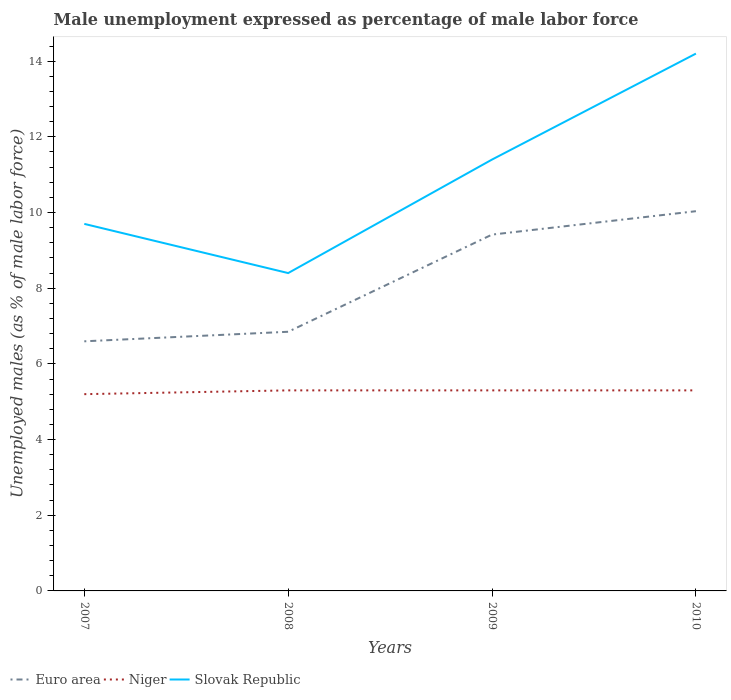Does the line corresponding to Slovak Republic intersect with the line corresponding to Euro area?
Give a very brief answer. No. Across all years, what is the maximum unemployment in males in in Euro area?
Your answer should be compact. 6.6. In which year was the unemployment in males in in Slovak Republic maximum?
Give a very brief answer. 2008. What is the total unemployment in males in in Niger in the graph?
Your response must be concise. -0.1. What is the difference between the highest and the second highest unemployment in males in in Euro area?
Ensure brevity in your answer.  3.44. What is the difference between the highest and the lowest unemployment in males in in Niger?
Your answer should be compact. 3. How many years are there in the graph?
Offer a terse response. 4. Does the graph contain any zero values?
Keep it short and to the point. No. Where does the legend appear in the graph?
Your answer should be compact. Bottom left. How many legend labels are there?
Provide a short and direct response. 3. How are the legend labels stacked?
Give a very brief answer. Horizontal. What is the title of the graph?
Give a very brief answer. Male unemployment expressed as percentage of male labor force. Does "Turkmenistan" appear as one of the legend labels in the graph?
Make the answer very short. No. What is the label or title of the X-axis?
Give a very brief answer. Years. What is the label or title of the Y-axis?
Your response must be concise. Unemployed males (as % of male labor force). What is the Unemployed males (as % of male labor force) of Euro area in 2007?
Provide a short and direct response. 6.6. What is the Unemployed males (as % of male labor force) of Niger in 2007?
Make the answer very short. 5.2. What is the Unemployed males (as % of male labor force) of Slovak Republic in 2007?
Ensure brevity in your answer.  9.7. What is the Unemployed males (as % of male labor force) in Euro area in 2008?
Ensure brevity in your answer.  6.85. What is the Unemployed males (as % of male labor force) in Niger in 2008?
Provide a succinct answer. 5.3. What is the Unemployed males (as % of male labor force) in Slovak Republic in 2008?
Keep it short and to the point. 8.4. What is the Unemployed males (as % of male labor force) in Euro area in 2009?
Keep it short and to the point. 9.42. What is the Unemployed males (as % of male labor force) of Niger in 2009?
Offer a terse response. 5.3. What is the Unemployed males (as % of male labor force) in Slovak Republic in 2009?
Provide a short and direct response. 11.4. What is the Unemployed males (as % of male labor force) in Euro area in 2010?
Provide a succinct answer. 10.04. What is the Unemployed males (as % of male labor force) of Niger in 2010?
Provide a short and direct response. 5.3. What is the Unemployed males (as % of male labor force) in Slovak Republic in 2010?
Make the answer very short. 14.2. Across all years, what is the maximum Unemployed males (as % of male labor force) in Euro area?
Offer a very short reply. 10.04. Across all years, what is the maximum Unemployed males (as % of male labor force) of Niger?
Your answer should be compact. 5.3. Across all years, what is the maximum Unemployed males (as % of male labor force) of Slovak Republic?
Ensure brevity in your answer.  14.2. Across all years, what is the minimum Unemployed males (as % of male labor force) in Euro area?
Ensure brevity in your answer.  6.6. Across all years, what is the minimum Unemployed males (as % of male labor force) of Niger?
Provide a succinct answer. 5.2. Across all years, what is the minimum Unemployed males (as % of male labor force) in Slovak Republic?
Your response must be concise. 8.4. What is the total Unemployed males (as % of male labor force) of Euro area in the graph?
Offer a very short reply. 32.9. What is the total Unemployed males (as % of male labor force) in Niger in the graph?
Your response must be concise. 21.1. What is the total Unemployed males (as % of male labor force) of Slovak Republic in the graph?
Offer a terse response. 43.7. What is the difference between the Unemployed males (as % of male labor force) of Euro area in 2007 and that in 2008?
Give a very brief answer. -0.25. What is the difference between the Unemployed males (as % of male labor force) of Niger in 2007 and that in 2008?
Give a very brief answer. -0.1. What is the difference between the Unemployed males (as % of male labor force) of Euro area in 2007 and that in 2009?
Provide a succinct answer. -2.82. What is the difference between the Unemployed males (as % of male labor force) of Euro area in 2007 and that in 2010?
Ensure brevity in your answer.  -3.44. What is the difference between the Unemployed males (as % of male labor force) of Niger in 2007 and that in 2010?
Ensure brevity in your answer.  -0.1. What is the difference between the Unemployed males (as % of male labor force) in Slovak Republic in 2007 and that in 2010?
Offer a terse response. -4.5. What is the difference between the Unemployed males (as % of male labor force) in Euro area in 2008 and that in 2009?
Your answer should be very brief. -2.57. What is the difference between the Unemployed males (as % of male labor force) in Niger in 2008 and that in 2009?
Your answer should be very brief. 0. What is the difference between the Unemployed males (as % of male labor force) of Slovak Republic in 2008 and that in 2009?
Offer a terse response. -3. What is the difference between the Unemployed males (as % of male labor force) of Euro area in 2008 and that in 2010?
Make the answer very short. -3.19. What is the difference between the Unemployed males (as % of male labor force) of Euro area in 2009 and that in 2010?
Keep it short and to the point. -0.62. What is the difference between the Unemployed males (as % of male labor force) in Euro area in 2007 and the Unemployed males (as % of male labor force) in Niger in 2008?
Provide a succinct answer. 1.3. What is the difference between the Unemployed males (as % of male labor force) of Euro area in 2007 and the Unemployed males (as % of male labor force) of Slovak Republic in 2008?
Offer a very short reply. -1.8. What is the difference between the Unemployed males (as % of male labor force) in Niger in 2007 and the Unemployed males (as % of male labor force) in Slovak Republic in 2008?
Ensure brevity in your answer.  -3.2. What is the difference between the Unemployed males (as % of male labor force) in Euro area in 2007 and the Unemployed males (as % of male labor force) in Niger in 2009?
Make the answer very short. 1.3. What is the difference between the Unemployed males (as % of male labor force) of Euro area in 2007 and the Unemployed males (as % of male labor force) of Slovak Republic in 2009?
Your answer should be compact. -4.8. What is the difference between the Unemployed males (as % of male labor force) of Niger in 2007 and the Unemployed males (as % of male labor force) of Slovak Republic in 2009?
Offer a very short reply. -6.2. What is the difference between the Unemployed males (as % of male labor force) in Euro area in 2007 and the Unemployed males (as % of male labor force) in Niger in 2010?
Offer a very short reply. 1.3. What is the difference between the Unemployed males (as % of male labor force) of Euro area in 2007 and the Unemployed males (as % of male labor force) of Slovak Republic in 2010?
Your answer should be compact. -7.6. What is the difference between the Unemployed males (as % of male labor force) of Niger in 2007 and the Unemployed males (as % of male labor force) of Slovak Republic in 2010?
Your response must be concise. -9. What is the difference between the Unemployed males (as % of male labor force) in Euro area in 2008 and the Unemployed males (as % of male labor force) in Niger in 2009?
Offer a very short reply. 1.55. What is the difference between the Unemployed males (as % of male labor force) in Euro area in 2008 and the Unemployed males (as % of male labor force) in Slovak Republic in 2009?
Ensure brevity in your answer.  -4.55. What is the difference between the Unemployed males (as % of male labor force) in Euro area in 2008 and the Unemployed males (as % of male labor force) in Niger in 2010?
Make the answer very short. 1.55. What is the difference between the Unemployed males (as % of male labor force) in Euro area in 2008 and the Unemployed males (as % of male labor force) in Slovak Republic in 2010?
Provide a short and direct response. -7.35. What is the difference between the Unemployed males (as % of male labor force) of Euro area in 2009 and the Unemployed males (as % of male labor force) of Niger in 2010?
Your response must be concise. 4.12. What is the difference between the Unemployed males (as % of male labor force) in Euro area in 2009 and the Unemployed males (as % of male labor force) in Slovak Republic in 2010?
Provide a short and direct response. -4.78. What is the difference between the Unemployed males (as % of male labor force) of Niger in 2009 and the Unemployed males (as % of male labor force) of Slovak Republic in 2010?
Your response must be concise. -8.9. What is the average Unemployed males (as % of male labor force) of Euro area per year?
Offer a terse response. 8.22. What is the average Unemployed males (as % of male labor force) in Niger per year?
Your response must be concise. 5.28. What is the average Unemployed males (as % of male labor force) of Slovak Republic per year?
Offer a very short reply. 10.93. In the year 2007, what is the difference between the Unemployed males (as % of male labor force) in Euro area and Unemployed males (as % of male labor force) in Niger?
Your answer should be compact. 1.4. In the year 2007, what is the difference between the Unemployed males (as % of male labor force) of Euro area and Unemployed males (as % of male labor force) of Slovak Republic?
Your answer should be very brief. -3.1. In the year 2007, what is the difference between the Unemployed males (as % of male labor force) in Niger and Unemployed males (as % of male labor force) in Slovak Republic?
Ensure brevity in your answer.  -4.5. In the year 2008, what is the difference between the Unemployed males (as % of male labor force) in Euro area and Unemployed males (as % of male labor force) in Niger?
Offer a very short reply. 1.55. In the year 2008, what is the difference between the Unemployed males (as % of male labor force) in Euro area and Unemployed males (as % of male labor force) in Slovak Republic?
Give a very brief answer. -1.55. In the year 2008, what is the difference between the Unemployed males (as % of male labor force) of Niger and Unemployed males (as % of male labor force) of Slovak Republic?
Provide a succinct answer. -3.1. In the year 2009, what is the difference between the Unemployed males (as % of male labor force) of Euro area and Unemployed males (as % of male labor force) of Niger?
Ensure brevity in your answer.  4.12. In the year 2009, what is the difference between the Unemployed males (as % of male labor force) of Euro area and Unemployed males (as % of male labor force) of Slovak Republic?
Your response must be concise. -1.98. In the year 2010, what is the difference between the Unemployed males (as % of male labor force) in Euro area and Unemployed males (as % of male labor force) in Niger?
Your answer should be compact. 4.74. In the year 2010, what is the difference between the Unemployed males (as % of male labor force) of Euro area and Unemployed males (as % of male labor force) of Slovak Republic?
Your answer should be very brief. -4.16. In the year 2010, what is the difference between the Unemployed males (as % of male labor force) of Niger and Unemployed males (as % of male labor force) of Slovak Republic?
Offer a very short reply. -8.9. What is the ratio of the Unemployed males (as % of male labor force) in Euro area in 2007 to that in 2008?
Provide a short and direct response. 0.96. What is the ratio of the Unemployed males (as % of male labor force) in Niger in 2007 to that in 2008?
Keep it short and to the point. 0.98. What is the ratio of the Unemployed males (as % of male labor force) of Slovak Republic in 2007 to that in 2008?
Provide a short and direct response. 1.15. What is the ratio of the Unemployed males (as % of male labor force) of Euro area in 2007 to that in 2009?
Offer a very short reply. 0.7. What is the ratio of the Unemployed males (as % of male labor force) of Niger in 2007 to that in 2009?
Provide a succinct answer. 0.98. What is the ratio of the Unemployed males (as % of male labor force) of Slovak Republic in 2007 to that in 2009?
Offer a terse response. 0.85. What is the ratio of the Unemployed males (as % of male labor force) of Euro area in 2007 to that in 2010?
Your response must be concise. 0.66. What is the ratio of the Unemployed males (as % of male labor force) of Niger in 2007 to that in 2010?
Give a very brief answer. 0.98. What is the ratio of the Unemployed males (as % of male labor force) of Slovak Republic in 2007 to that in 2010?
Keep it short and to the point. 0.68. What is the ratio of the Unemployed males (as % of male labor force) in Euro area in 2008 to that in 2009?
Give a very brief answer. 0.73. What is the ratio of the Unemployed males (as % of male labor force) of Slovak Republic in 2008 to that in 2009?
Your response must be concise. 0.74. What is the ratio of the Unemployed males (as % of male labor force) of Euro area in 2008 to that in 2010?
Provide a succinct answer. 0.68. What is the ratio of the Unemployed males (as % of male labor force) of Slovak Republic in 2008 to that in 2010?
Offer a terse response. 0.59. What is the ratio of the Unemployed males (as % of male labor force) in Euro area in 2009 to that in 2010?
Your answer should be very brief. 0.94. What is the ratio of the Unemployed males (as % of male labor force) in Niger in 2009 to that in 2010?
Make the answer very short. 1. What is the ratio of the Unemployed males (as % of male labor force) of Slovak Republic in 2009 to that in 2010?
Keep it short and to the point. 0.8. What is the difference between the highest and the second highest Unemployed males (as % of male labor force) of Euro area?
Offer a very short reply. 0.62. What is the difference between the highest and the second highest Unemployed males (as % of male labor force) of Niger?
Provide a short and direct response. 0. What is the difference between the highest and the second highest Unemployed males (as % of male labor force) in Slovak Republic?
Provide a short and direct response. 2.8. What is the difference between the highest and the lowest Unemployed males (as % of male labor force) in Euro area?
Your answer should be compact. 3.44. What is the difference between the highest and the lowest Unemployed males (as % of male labor force) in Niger?
Offer a terse response. 0.1. 